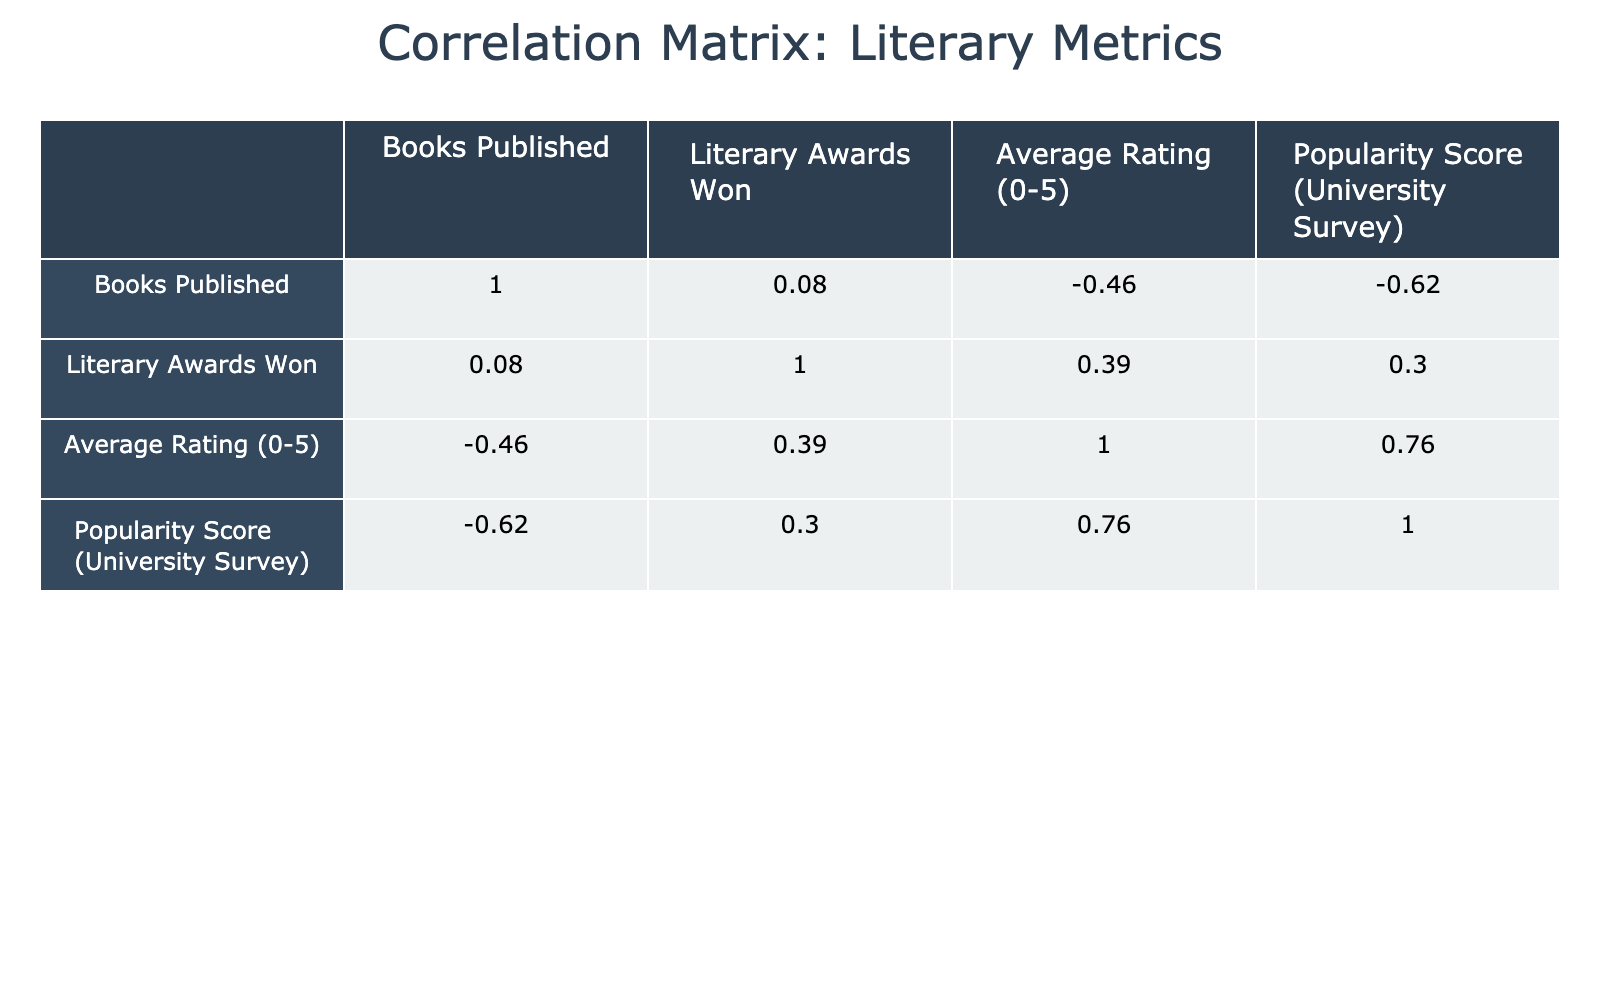What is the correlation coefficient between Literary Awards Won and Popularity Score? To find the correlation coefficient between Literary Awards Won and Popularity Score, we look at the correlation matrix table where the intersection of these two variables is located. The table shows a value of 0.65 for this correlation, indicating a moderate positive relationship.
Answer: 0.65 Which author has the highest Average Rating? We can identify the author with the highest Average Rating by scanning the Average Rating column for the largest number. In this case, Harper Lee has the highest Average Rating of 4.7.
Answer: Harper Lee Is there a negative correlation between the number of Books Published and Popularity Score? We check the correlation coefficient between Books Published and Popularity Score in the correlation matrix. The value is 0.04, which is close to zero and indicates no negative correlation. Therefore, we can conclude it is false.
Answer: No Calculate the average number of Literary Awards won by the authors listed. To find the average number of Literary Awards, we sum the values in the Literary Awards Won column (2 + 3 + 1 + 1 + 2 + 2 + 4 + 1 + 1 + 2 = 20) and then divide by the number of authors (10). Thus, the average is 20 / 10 = 2.
Answer: 2 Are there more authors with an Average Rating above 4.5 than below? We can count the number of authors with an Average Rating above 4.5 (Virginia Woolf, Harper Lee, Margaret Atwood) which is 3 and those with ratings below 4.5 (R.C. Sherriff, George Orwell, T.S. Eliot, Kazuo Ishiguro, Philip Roth, Zadie Smith, Doris Lessing) which is 7. Since there are more authors below, the answer is no.
Answer: No What is the correlation between Books Published and Literary Awards Won? The correlation coefficient between Books Published and Literary Awards Won can be found at their intersection in the correlation matrix table. The correlation coefficient is 0.28, indicating a weak positive correlation.
Answer: 0.28 